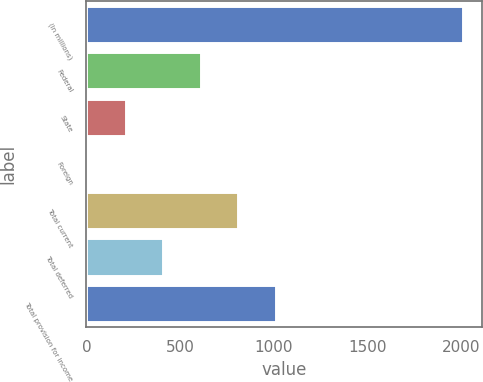<chart> <loc_0><loc_0><loc_500><loc_500><bar_chart><fcel>(In millions)<fcel>Federal<fcel>State<fcel>Foreign<fcel>Total current<fcel>Total deferred<fcel>Total provision for income<nl><fcel>2014<fcel>611.2<fcel>210.4<fcel>10<fcel>811.6<fcel>410.8<fcel>1012<nl></chart> 